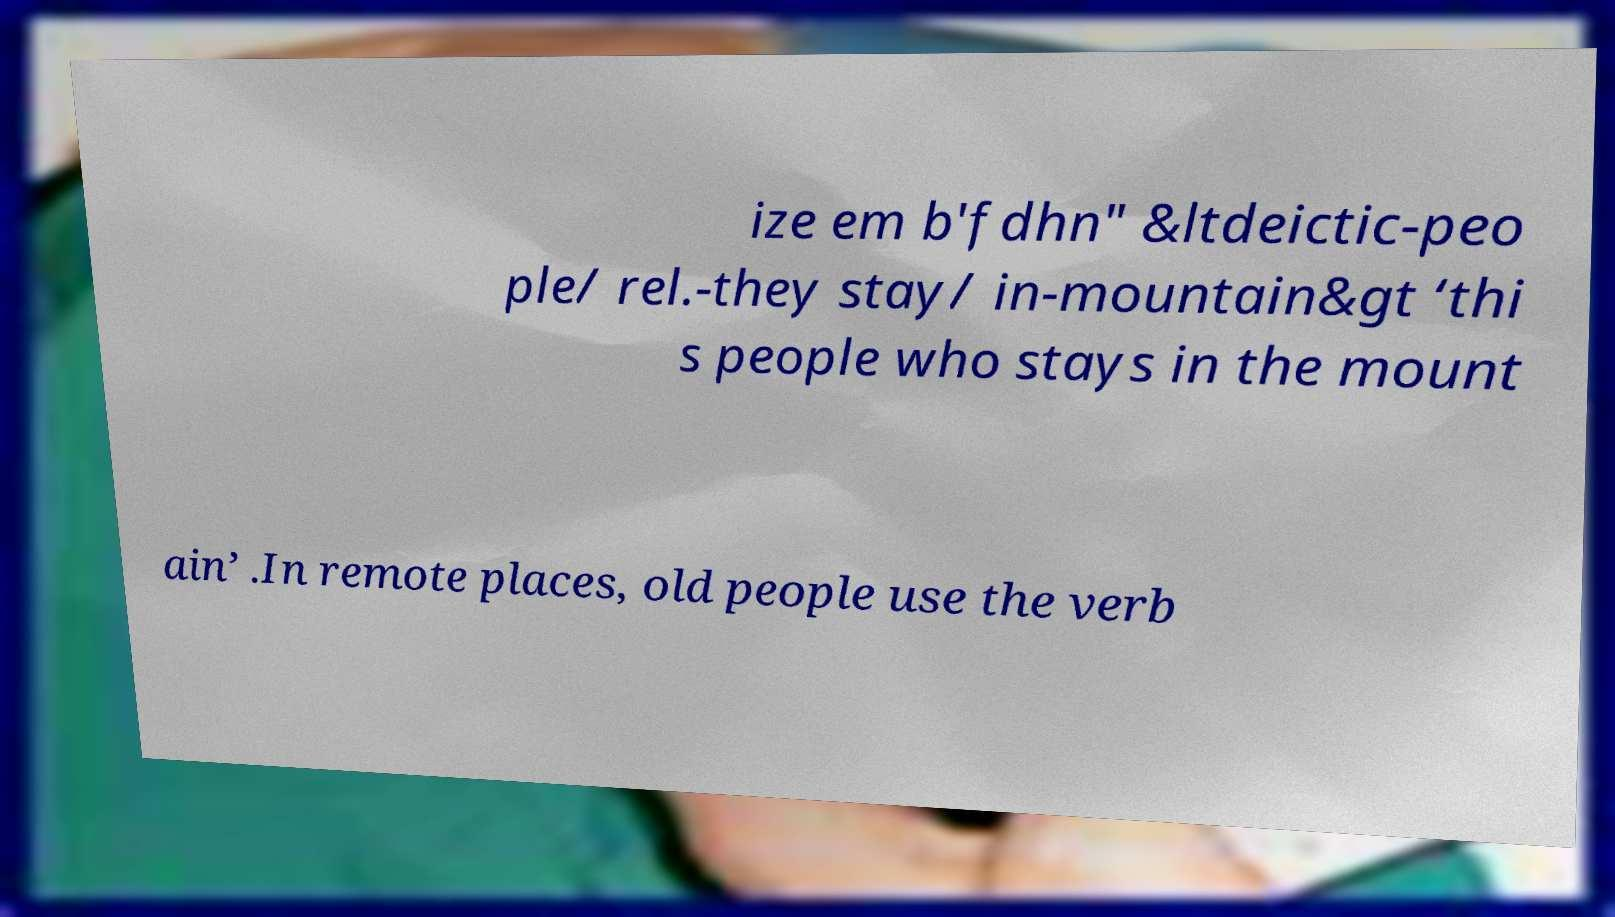There's text embedded in this image that I need extracted. Can you transcribe it verbatim? ize em b'fdhn" &ltdeictic-peo ple/ rel.-they stay/ in-mountain&gt ‘thi s people who stays in the mount ain’ .In remote places, old people use the verb 